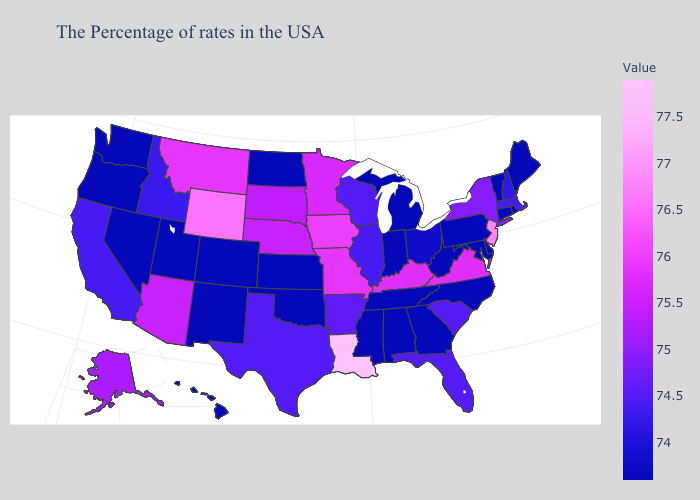Among the states that border Florida , which have the lowest value?
Be succinct. Georgia, Alabama. Which states hav the highest value in the West?
Be succinct. Wyoming. Does Arkansas have the lowest value in the USA?
Write a very short answer. No. Among the states that border New York , which have the lowest value?
Give a very brief answer. Vermont, Connecticut, Pennsylvania. Is the legend a continuous bar?
Quick response, please. Yes. Among the states that border Florida , which have the highest value?
Answer briefly. Georgia, Alabama. Which states have the highest value in the USA?
Answer briefly. Louisiana. 